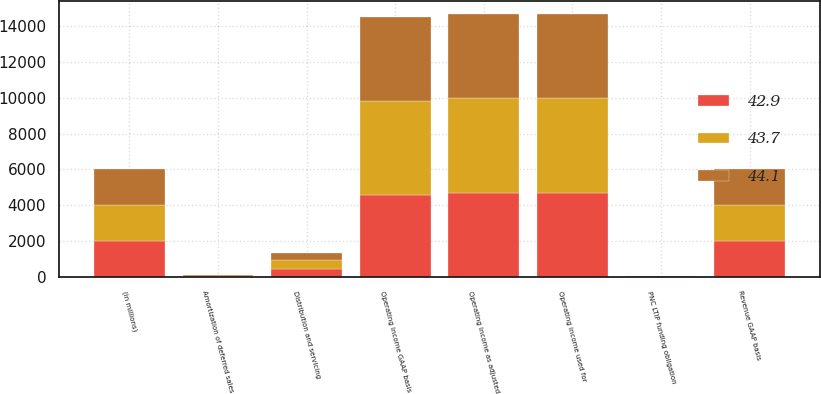Convert chart to OTSL. <chart><loc_0><loc_0><loc_500><loc_500><stacked_bar_chart><ecel><fcel>(in millions)<fcel>Operating income GAAP basis<fcel>PNC LTIP funding obligation<fcel>Operating income as adjusted<fcel>Operating income used for<fcel>Revenue GAAP basis<fcel>Distribution and servicing<fcel>Amortization of deferred sales<nl><fcel>43.7<fcel>2017<fcel>5272<fcel>15<fcel>5287<fcel>5287<fcel>2016<fcel>492<fcel>17<nl><fcel>42.9<fcel>2016<fcel>4570<fcel>28<fcel>4674<fcel>4674<fcel>2016<fcel>429<fcel>34<nl><fcel>44.1<fcel>2015<fcel>4664<fcel>30<fcel>4695<fcel>4700<fcel>2016<fcel>409<fcel>48<nl></chart> 